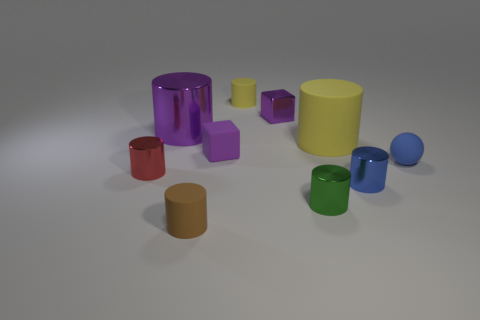Does the cube that is on the left side of the tiny purple metallic thing have the same color as the tiny rubber cylinder that is behind the red object?
Offer a very short reply. No. What is the size of the cylinder that is the same color as the tiny rubber sphere?
Make the answer very short. Small. Are there any small gray cylinders made of the same material as the tiny blue cylinder?
Offer a terse response. No. Are there the same number of brown matte objects that are on the left side of the purple cylinder and purple objects that are on the right side of the purple matte object?
Ensure brevity in your answer.  No. What size is the purple rubber thing left of the large yellow thing?
Ensure brevity in your answer.  Small. The yellow object that is behind the small metal object behind the large yellow cylinder is made of what material?
Offer a terse response. Rubber. There is a purple block that is behind the shiny cylinder that is behind the red thing; what number of rubber things are in front of it?
Offer a terse response. 4. Is the material of the yellow object to the left of the green thing the same as the blue object in front of the matte ball?
Provide a short and direct response. No. What is the material of the object that is the same color as the tiny matte ball?
Your response must be concise. Metal. How many big metallic things have the same shape as the small green object?
Offer a very short reply. 1. 